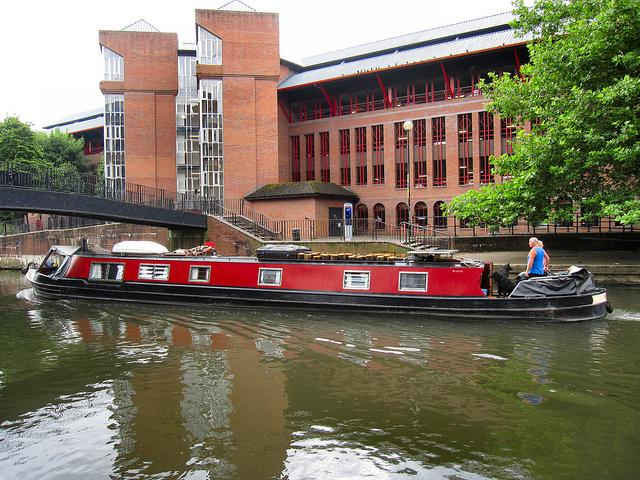How is this vessel being propelled?

Choices:
A) tugged
B) motor
C) wind
D) paddle motor 